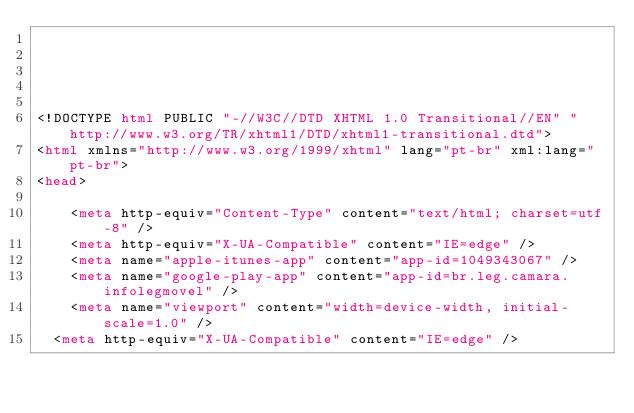Convert code to text. <code><loc_0><loc_0><loc_500><loc_500><_HTML_>




<!DOCTYPE html PUBLIC "-//W3C//DTD XHTML 1.0 Transitional//EN" "http://www.w3.org/TR/xhtml1/DTD/xhtml1-transitional.dtd">
<html xmlns="http://www.w3.org/1999/xhtml" lang="pt-br" xml:lang="pt-br">
<head>
	    
    <meta http-equiv="Content-Type" content="text/html; charset=utf-8" />
    <meta http-equiv="X-UA-Compatible" content="IE=edge" />
    <meta name="apple-itunes-app" content="app-id=1049343067" />
    <meta name="google-play-app" content="app-id=br.leg.camara.infolegmovel" />
    <meta name="viewport" content="width=device-width, initial-scale=1.0" />
	<meta http-equiv="X-UA-Compatible" content="IE=edge" /> 
    </code> 